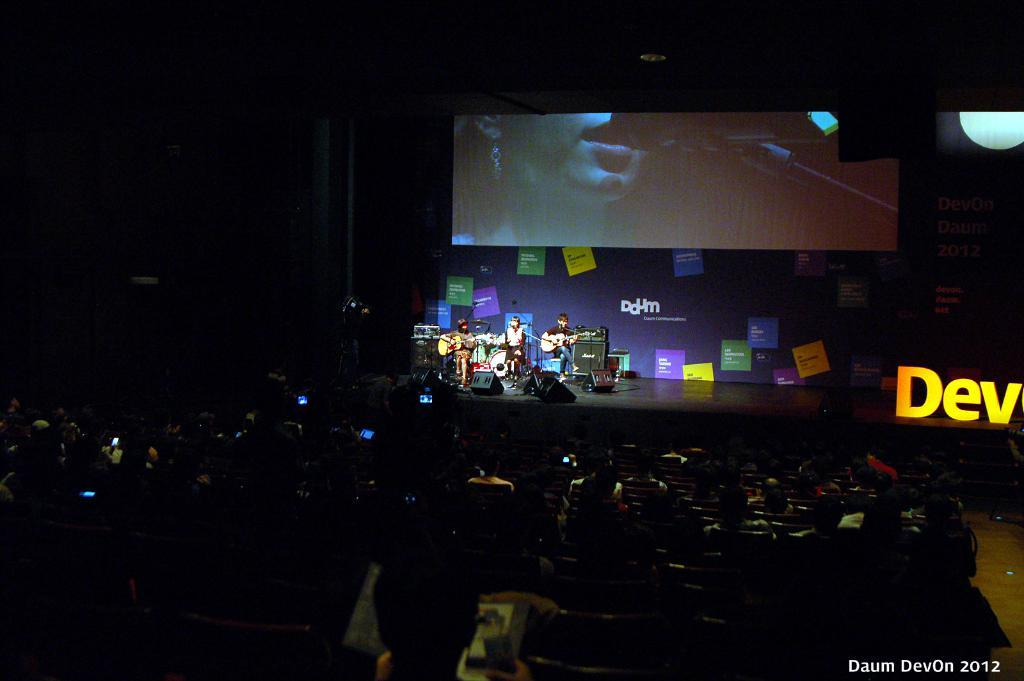What is happening on the stage in the image? There are people playing musical instruments on a stage. What can be seen behind the stage? There is a big screen behind the stage. What are the people sitting in front of the stage doing? These people are sitting on chairs and watching the performance. What type of vegetable is being used as a percussion instrument in the image? There is no vegetable being used as a percussion instrument in the image; the people are playing traditional musical instruments. 